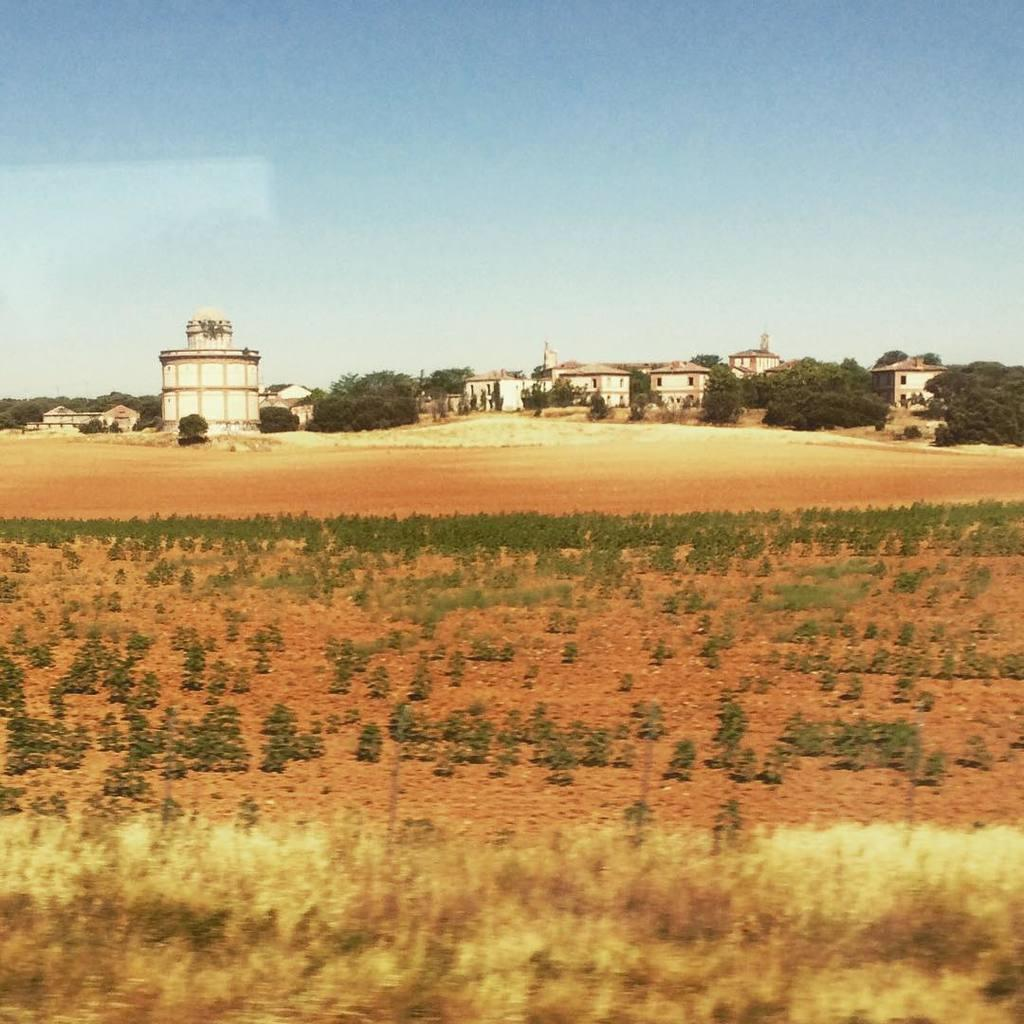What type of natural elements can be seen in the image? There are plants and trees in the image. What type of man-made structures are present in the image? There are buildings in the image. Can you describe the architectural style of the buildings? There is an architecture in the image, but the specific style is not mentioned. What is visible behind the buildings? The sky is visible behind the buildings. What type of drink is being served in the image? There is no drink present in the image. Can you describe the toe of the person in the image? There is no person present in the image, so there is no toe to describe. 